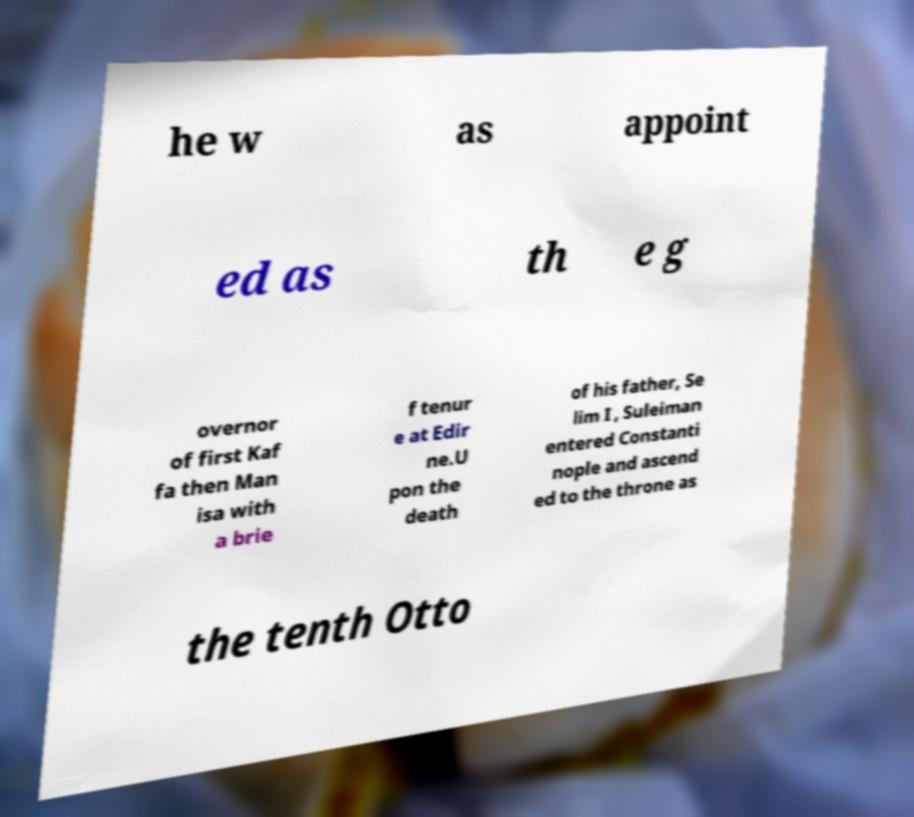Can you accurately transcribe the text from the provided image for me? he w as appoint ed as th e g overnor of first Kaf fa then Man isa with a brie f tenur e at Edir ne.U pon the death of his father, Se lim I , Suleiman entered Constanti nople and ascend ed to the throne as the tenth Otto 